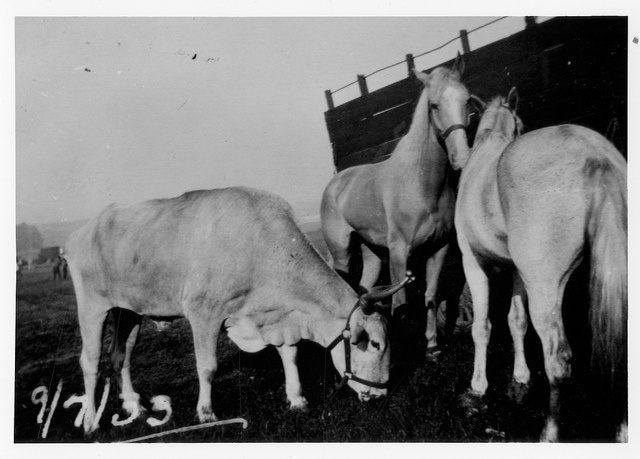Describe the objects in this image and their specific colors. I can see cow in white, darkgray, gray, black, and lightgray tones, horse in white, darkgray, gray, black, and lightgray tones, and horse in white, gray, black, and silver tones in this image. 